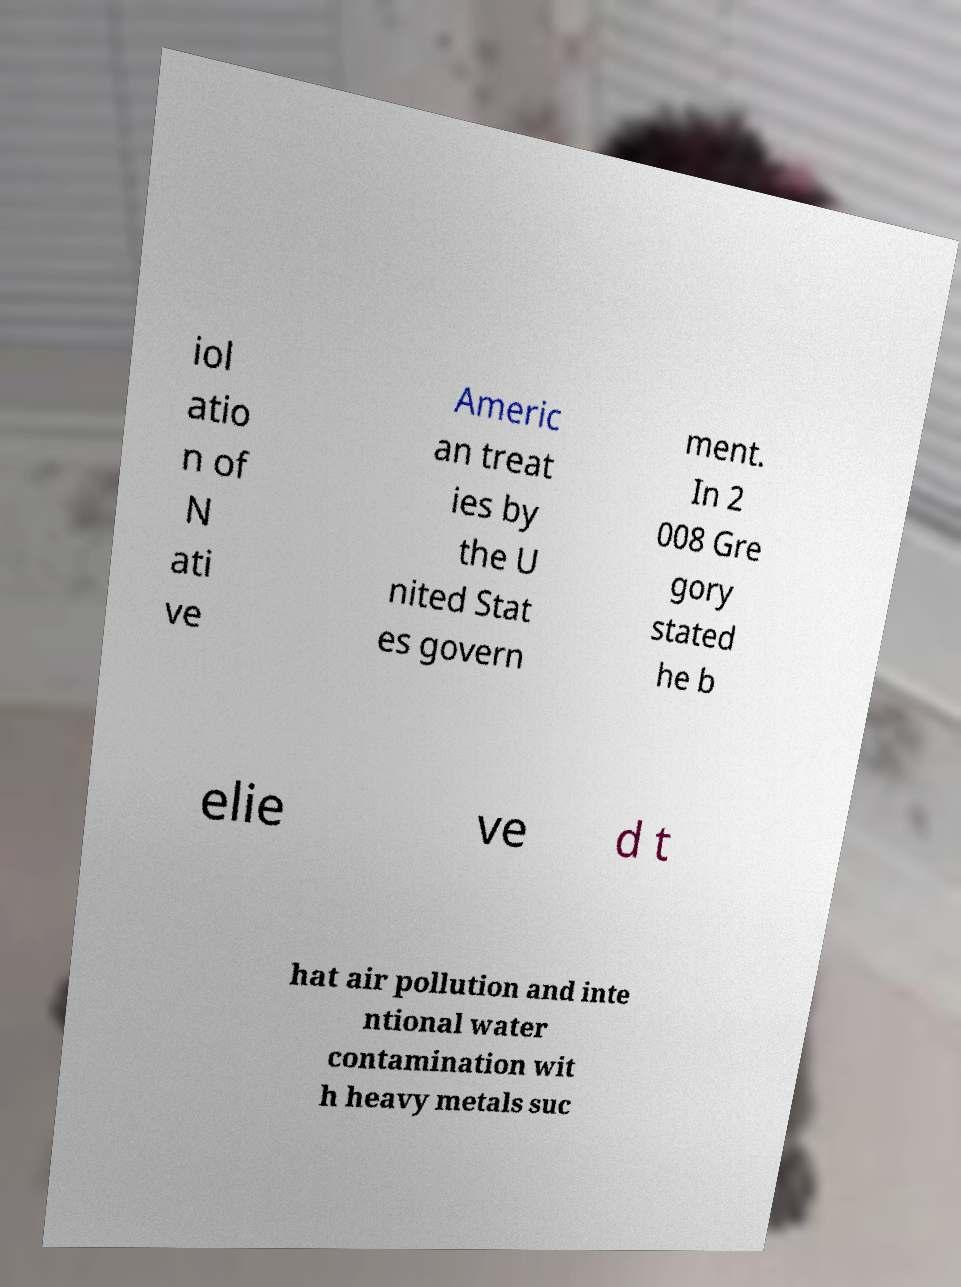Could you extract and type out the text from this image? iol atio n of N ati ve Americ an treat ies by the U nited Stat es govern ment. In 2 008 Gre gory stated he b elie ve d t hat air pollution and inte ntional water contamination wit h heavy metals suc 